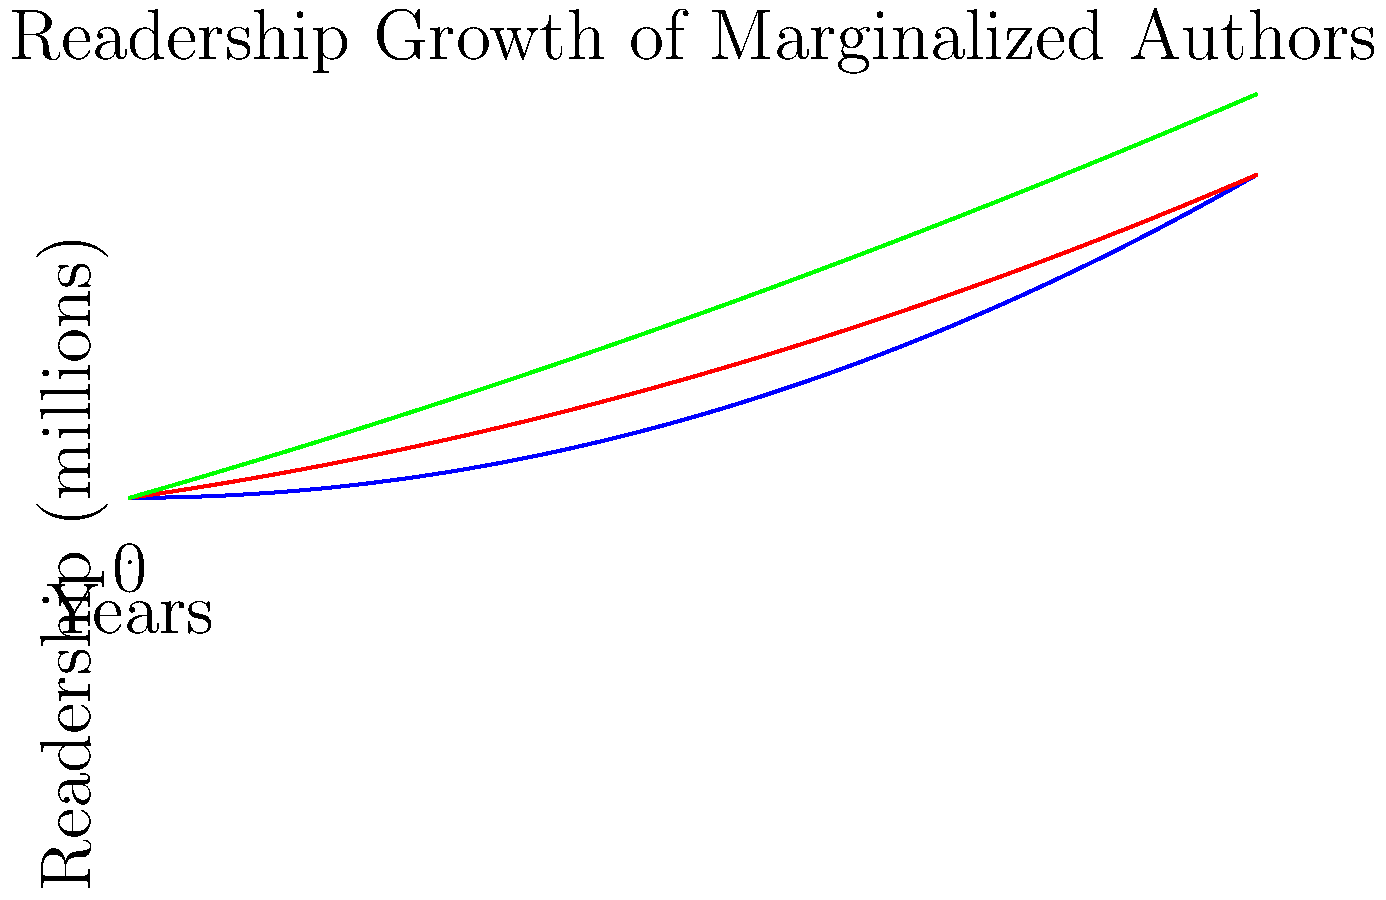Based on the line graph showing the readership growth of marginalized authors over a 5-year period, which group demonstrates the most significant increase in readership, and what strategy might you recommend to further amplify their voices on social media? To determine which group shows the most significant increase in readership and recommend a strategy, let's analyze the graph step-by-step:

1. Observe the three curves representing different groups of marginalized authors:
   - Blue curve (Group A)
   - Red curve (Group B)
   - Green curve (Group C)

2. Compare the slopes and end points of each curve:
   - Group A (Blue): Starts lowest but has the steepest curve
   - Group B (Red): Starts in the middle and has a moderate increase
   - Group C (Green): Starts highest and has the most gradual increase

3. Calculate the approximate growth for each group:
   - Group A: From ~1 million to ~6 million readers (5x increase)
   - Group B: From ~1.5 million to ~4.5 million readers (3x increase)
   - Group C: From ~2 million to ~4 million readers (2x increase)

4. Conclusion: Group A shows the most significant increase in readership, growing from the smallest initial readership to the largest over the 5-year period.

5. Strategy recommendation:
   Given Group A's rapid growth, a strategy to further amplify their voices on social media could include:
   - Creating a dedicated hashtag for Group A authors
   - Organizing virtual book clubs or reading challenges featuring Group A authors
   - Collaborating with influencers to promote Group A authors' works
   - Sharing behind-the-scenes content or author interviews to personalize the reading experience

This approach capitalizes on the existing momentum of Group A while providing targeted support to maintain and accelerate their growth trajectory.
Answer: Group A; create a dedicated hashtag and organize virtual events featuring Group A authors. 